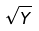Convert formula to latex. <formula><loc_0><loc_0><loc_500><loc_500>\sqrt { Y }</formula> 